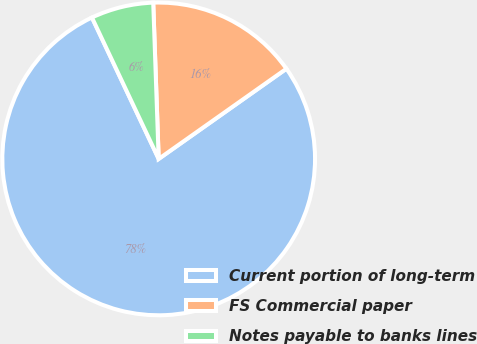<chart> <loc_0><loc_0><loc_500><loc_500><pie_chart><fcel>Current portion of long-term<fcel>FS Commercial paper<fcel>Notes payable to banks lines<nl><fcel>77.76%<fcel>15.77%<fcel>6.46%<nl></chart> 